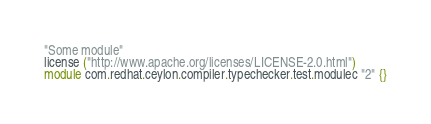Convert code to text. <code><loc_0><loc_0><loc_500><loc_500><_Ceylon_>"Some module"
license ("http://www.apache.org/licenses/LICENSE-2.0.html")
module com.redhat.ceylon.compiler.typechecker.test.modulec "2" {}</code> 